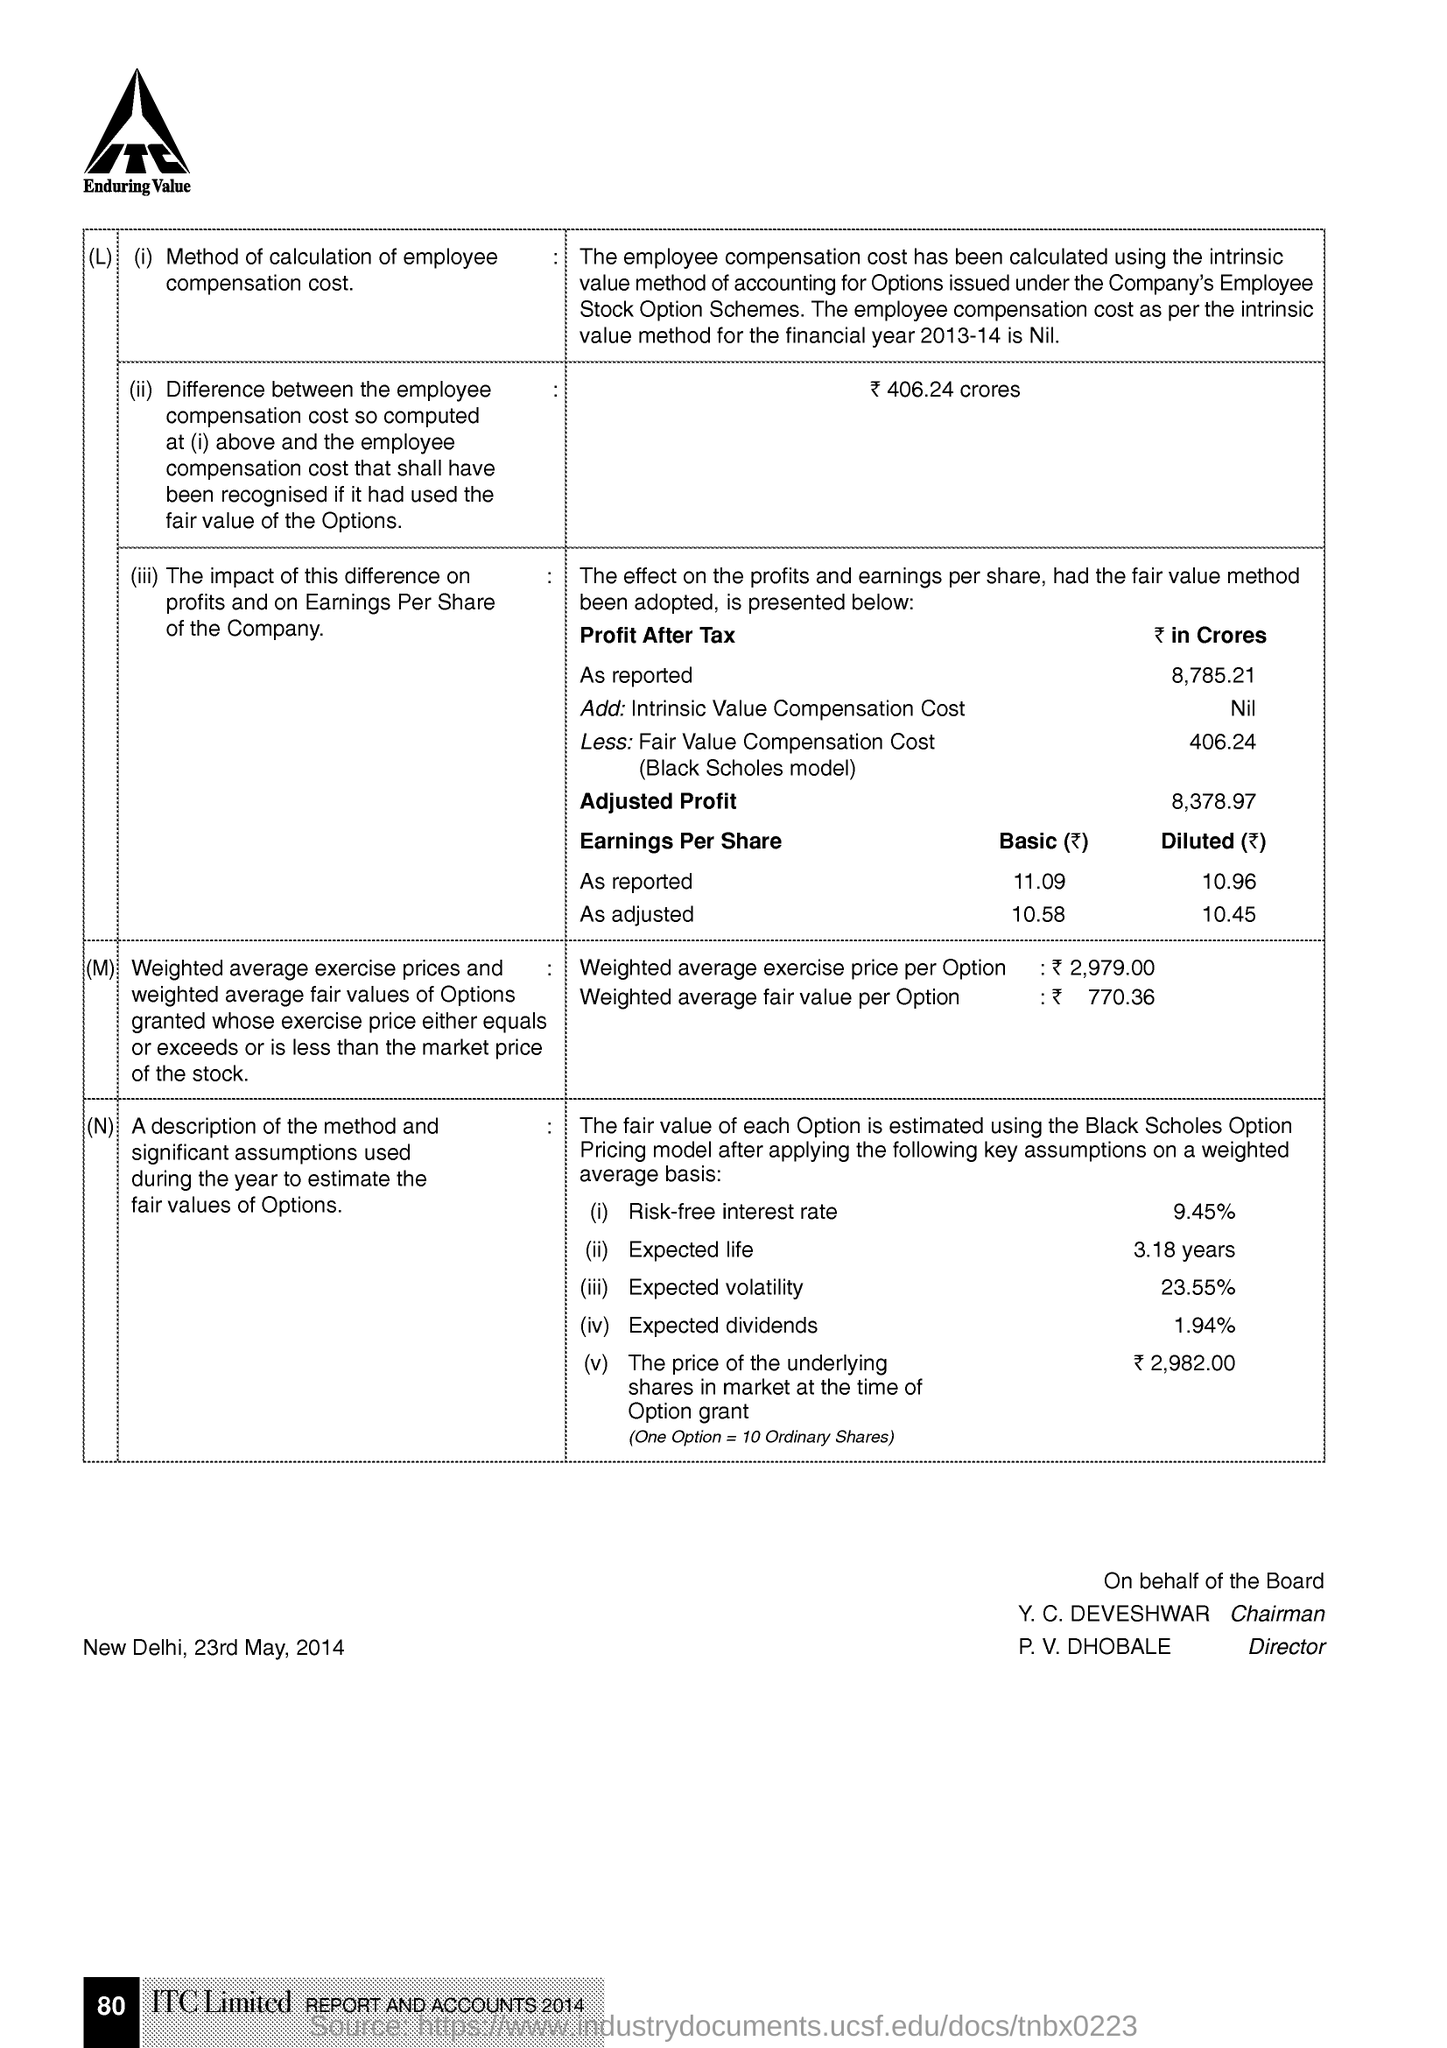What is the Place & Date mentioned in this document?
Ensure brevity in your answer.  New Delhi, 23rd May, 2014. What is the page no mentioned in this document?
Provide a succinct answer. 80. 